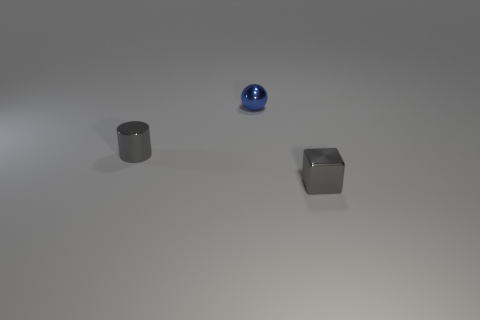Add 1 small brown cylinders. How many objects exist? 4 Subtract all spheres. How many objects are left? 2 Add 3 gray shiny cylinders. How many gray shiny cylinders exist? 4 Subtract 0 brown cylinders. How many objects are left? 3 Subtract all blue things. Subtract all yellow metallic spheres. How many objects are left? 2 Add 1 small shiny things. How many small shiny things are left? 4 